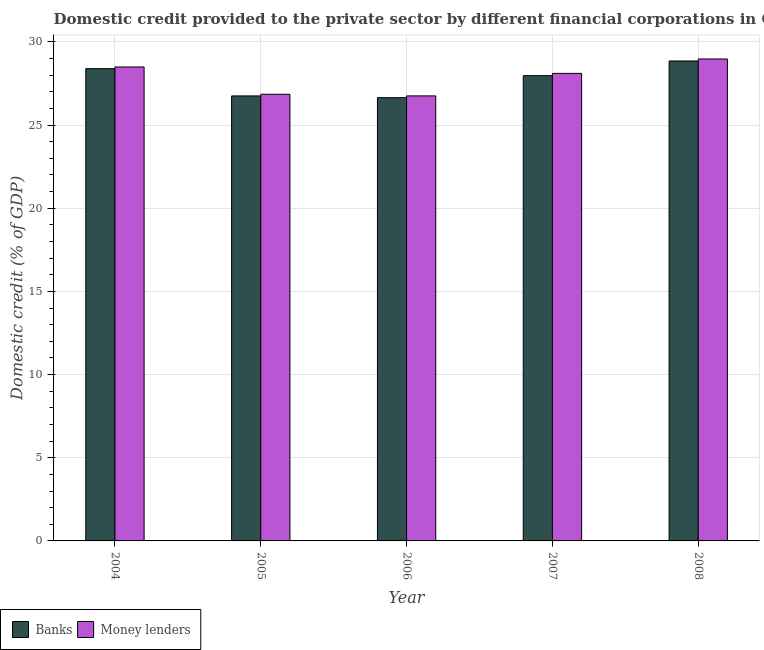How many different coloured bars are there?
Ensure brevity in your answer.  2. Are the number of bars on each tick of the X-axis equal?
Keep it short and to the point. Yes. How many bars are there on the 1st tick from the left?
Provide a short and direct response. 2. How many bars are there on the 5th tick from the right?
Your answer should be very brief. 2. What is the domestic credit provided by money lenders in 2005?
Your answer should be compact. 26.85. Across all years, what is the maximum domestic credit provided by money lenders?
Offer a terse response. 28.97. Across all years, what is the minimum domestic credit provided by money lenders?
Provide a succinct answer. 26.75. In which year was the domestic credit provided by money lenders minimum?
Make the answer very short. 2006. What is the total domestic credit provided by money lenders in the graph?
Ensure brevity in your answer.  139.16. What is the difference between the domestic credit provided by banks in 2005 and that in 2008?
Offer a very short reply. -2.1. What is the difference between the domestic credit provided by money lenders in 2005 and the domestic credit provided by banks in 2004?
Your answer should be very brief. -1.64. What is the average domestic credit provided by money lenders per year?
Make the answer very short. 27.83. What is the ratio of the domestic credit provided by banks in 2006 to that in 2007?
Your response must be concise. 0.95. Is the domestic credit provided by banks in 2005 less than that in 2008?
Offer a very short reply. Yes. What is the difference between the highest and the second highest domestic credit provided by banks?
Offer a terse response. 0.46. What is the difference between the highest and the lowest domestic credit provided by banks?
Your answer should be compact. 2.21. In how many years, is the domestic credit provided by money lenders greater than the average domestic credit provided by money lenders taken over all years?
Your answer should be very brief. 3. Is the sum of the domestic credit provided by money lenders in 2004 and 2005 greater than the maximum domestic credit provided by banks across all years?
Provide a short and direct response. Yes. What does the 2nd bar from the left in 2006 represents?
Keep it short and to the point. Money lenders. What does the 2nd bar from the right in 2006 represents?
Provide a succinct answer. Banks. How many bars are there?
Ensure brevity in your answer.  10. Are all the bars in the graph horizontal?
Offer a very short reply. No. What is the difference between two consecutive major ticks on the Y-axis?
Offer a terse response. 5. Are the values on the major ticks of Y-axis written in scientific E-notation?
Keep it short and to the point. No. Where does the legend appear in the graph?
Your answer should be compact. Bottom left. How many legend labels are there?
Provide a succinct answer. 2. How are the legend labels stacked?
Your answer should be compact. Horizontal. What is the title of the graph?
Your response must be concise. Domestic credit provided to the private sector by different financial corporations in Other small states. What is the label or title of the X-axis?
Make the answer very short. Year. What is the label or title of the Y-axis?
Give a very brief answer. Domestic credit (% of GDP). What is the Domestic credit (% of GDP) in Banks in 2004?
Provide a short and direct response. 28.39. What is the Domestic credit (% of GDP) of Money lenders in 2004?
Provide a succinct answer. 28.49. What is the Domestic credit (% of GDP) of Banks in 2005?
Provide a succinct answer. 26.75. What is the Domestic credit (% of GDP) in Money lenders in 2005?
Provide a short and direct response. 26.85. What is the Domestic credit (% of GDP) in Banks in 2006?
Your answer should be very brief. 26.64. What is the Domestic credit (% of GDP) in Money lenders in 2006?
Offer a terse response. 26.75. What is the Domestic credit (% of GDP) of Banks in 2007?
Ensure brevity in your answer.  27.97. What is the Domestic credit (% of GDP) of Money lenders in 2007?
Offer a very short reply. 28.1. What is the Domestic credit (% of GDP) in Banks in 2008?
Your answer should be very brief. 28.85. What is the Domestic credit (% of GDP) of Money lenders in 2008?
Make the answer very short. 28.97. Across all years, what is the maximum Domestic credit (% of GDP) of Banks?
Your answer should be very brief. 28.85. Across all years, what is the maximum Domestic credit (% of GDP) of Money lenders?
Ensure brevity in your answer.  28.97. Across all years, what is the minimum Domestic credit (% of GDP) of Banks?
Your answer should be very brief. 26.64. Across all years, what is the minimum Domestic credit (% of GDP) of Money lenders?
Provide a succinct answer. 26.75. What is the total Domestic credit (% of GDP) of Banks in the graph?
Give a very brief answer. 138.6. What is the total Domestic credit (% of GDP) in Money lenders in the graph?
Provide a short and direct response. 139.16. What is the difference between the Domestic credit (% of GDP) in Banks in 2004 and that in 2005?
Offer a terse response. 1.64. What is the difference between the Domestic credit (% of GDP) in Money lenders in 2004 and that in 2005?
Offer a very short reply. 1.64. What is the difference between the Domestic credit (% of GDP) in Banks in 2004 and that in 2006?
Provide a succinct answer. 1.74. What is the difference between the Domestic credit (% of GDP) in Money lenders in 2004 and that in 2006?
Your answer should be compact. 1.74. What is the difference between the Domestic credit (% of GDP) in Banks in 2004 and that in 2007?
Your response must be concise. 0.42. What is the difference between the Domestic credit (% of GDP) of Money lenders in 2004 and that in 2007?
Your answer should be compact. 0.38. What is the difference between the Domestic credit (% of GDP) of Banks in 2004 and that in 2008?
Ensure brevity in your answer.  -0.46. What is the difference between the Domestic credit (% of GDP) of Money lenders in 2004 and that in 2008?
Ensure brevity in your answer.  -0.48. What is the difference between the Domestic credit (% of GDP) of Banks in 2005 and that in 2006?
Your answer should be compact. 0.11. What is the difference between the Domestic credit (% of GDP) in Money lenders in 2005 and that in 2006?
Your response must be concise. 0.1. What is the difference between the Domestic credit (% of GDP) of Banks in 2005 and that in 2007?
Your response must be concise. -1.22. What is the difference between the Domestic credit (% of GDP) in Money lenders in 2005 and that in 2007?
Offer a very short reply. -1.25. What is the difference between the Domestic credit (% of GDP) of Banks in 2005 and that in 2008?
Your answer should be compact. -2.1. What is the difference between the Domestic credit (% of GDP) in Money lenders in 2005 and that in 2008?
Offer a terse response. -2.12. What is the difference between the Domestic credit (% of GDP) of Banks in 2006 and that in 2007?
Ensure brevity in your answer.  -1.32. What is the difference between the Domestic credit (% of GDP) of Money lenders in 2006 and that in 2007?
Offer a very short reply. -1.35. What is the difference between the Domestic credit (% of GDP) of Banks in 2006 and that in 2008?
Your answer should be very brief. -2.21. What is the difference between the Domestic credit (% of GDP) in Money lenders in 2006 and that in 2008?
Your response must be concise. -2.22. What is the difference between the Domestic credit (% of GDP) of Banks in 2007 and that in 2008?
Make the answer very short. -0.88. What is the difference between the Domestic credit (% of GDP) in Money lenders in 2007 and that in 2008?
Your answer should be compact. -0.87. What is the difference between the Domestic credit (% of GDP) in Banks in 2004 and the Domestic credit (% of GDP) in Money lenders in 2005?
Offer a very short reply. 1.54. What is the difference between the Domestic credit (% of GDP) in Banks in 2004 and the Domestic credit (% of GDP) in Money lenders in 2006?
Provide a succinct answer. 1.64. What is the difference between the Domestic credit (% of GDP) in Banks in 2004 and the Domestic credit (% of GDP) in Money lenders in 2007?
Your response must be concise. 0.28. What is the difference between the Domestic credit (% of GDP) in Banks in 2004 and the Domestic credit (% of GDP) in Money lenders in 2008?
Provide a succinct answer. -0.58. What is the difference between the Domestic credit (% of GDP) of Banks in 2005 and the Domestic credit (% of GDP) of Money lenders in 2006?
Make the answer very short. -0. What is the difference between the Domestic credit (% of GDP) in Banks in 2005 and the Domestic credit (% of GDP) in Money lenders in 2007?
Your answer should be compact. -1.35. What is the difference between the Domestic credit (% of GDP) of Banks in 2005 and the Domestic credit (% of GDP) of Money lenders in 2008?
Your answer should be compact. -2.22. What is the difference between the Domestic credit (% of GDP) of Banks in 2006 and the Domestic credit (% of GDP) of Money lenders in 2007?
Keep it short and to the point. -1.46. What is the difference between the Domestic credit (% of GDP) of Banks in 2006 and the Domestic credit (% of GDP) of Money lenders in 2008?
Offer a terse response. -2.33. What is the difference between the Domestic credit (% of GDP) in Banks in 2007 and the Domestic credit (% of GDP) in Money lenders in 2008?
Provide a succinct answer. -1. What is the average Domestic credit (% of GDP) of Banks per year?
Keep it short and to the point. 27.72. What is the average Domestic credit (% of GDP) in Money lenders per year?
Give a very brief answer. 27.83. In the year 2004, what is the difference between the Domestic credit (% of GDP) of Banks and Domestic credit (% of GDP) of Money lenders?
Your response must be concise. -0.1. In the year 2005, what is the difference between the Domestic credit (% of GDP) of Banks and Domestic credit (% of GDP) of Money lenders?
Offer a terse response. -0.1. In the year 2006, what is the difference between the Domestic credit (% of GDP) of Banks and Domestic credit (% of GDP) of Money lenders?
Your answer should be very brief. -0.11. In the year 2007, what is the difference between the Domestic credit (% of GDP) of Banks and Domestic credit (% of GDP) of Money lenders?
Your response must be concise. -0.14. In the year 2008, what is the difference between the Domestic credit (% of GDP) in Banks and Domestic credit (% of GDP) in Money lenders?
Your answer should be very brief. -0.12. What is the ratio of the Domestic credit (% of GDP) in Banks in 2004 to that in 2005?
Offer a very short reply. 1.06. What is the ratio of the Domestic credit (% of GDP) in Money lenders in 2004 to that in 2005?
Your answer should be very brief. 1.06. What is the ratio of the Domestic credit (% of GDP) of Banks in 2004 to that in 2006?
Ensure brevity in your answer.  1.07. What is the ratio of the Domestic credit (% of GDP) of Money lenders in 2004 to that in 2006?
Your answer should be compact. 1.06. What is the ratio of the Domestic credit (% of GDP) of Money lenders in 2004 to that in 2007?
Provide a short and direct response. 1.01. What is the ratio of the Domestic credit (% of GDP) of Banks in 2004 to that in 2008?
Offer a very short reply. 0.98. What is the ratio of the Domestic credit (% of GDP) in Money lenders in 2004 to that in 2008?
Your response must be concise. 0.98. What is the ratio of the Domestic credit (% of GDP) of Money lenders in 2005 to that in 2006?
Keep it short and to the point. 1. What is the ratio of the Domestic credit (% of GDP) in Banks in 2005 to that in 2007?
Offer a very short reply. 0.96. What is the ratio of the Domestic credit (% of GDP) in Money lenders in 2005 to that in 2007?
Provide a short and direct response. 0.96. What is the ratio of the Domestic credit (% of GDP) of Banks in 2005 to that in 2008?
Keep it short and to the point. 0.93. What is the ratio of the Domestic credit (% of GDP) in Money lenders in 2005 to that in 2008?
Keep it short and to the point. 0.93. What is the ratio of the Domestic credit (% of GDP) of Banks in 2006 to that in 2007?
Make the answer very short. 0.95. What is the ratio of the Domestic credit (% of GDP) of Money lenders in 2006 to that in 2007?
Your answer should be compact. 0.95. What is the ratio of the Domestic credit (% of GDP) in Banks in 2006 to that in 2008?
Your answer should be compact. 0.92. What is the ratio of the Domestic credit (% of GDP) of Money lenders in 2006 to that in 2008?
Make the answer very short. 0.92. What is the ratio of the Domestic credit (% of GDP) of Banks in 2007 to that in 2008?
Make the answer very short. 0.97. What is the ratio of the Domestic credit (% of GDP) in Money lenders in 2007 to that in 2008?
Keep it short and to the point. 0.97. What is the difference between the highest and the second highest Domestic credit (% of GDP) of Banks?
Offer a very short reply. 0.46. What is the difference between the highest and the second highest Domestic credit (% of GDP) in Money lenders?
Your answer should be compact. 0.48. What is the difference between the highest and the lowest Domestic credit (% of GDP) in Banks?
Your response must be concise. 2.21. What is the difference between the highest and the lowest Domestic credit (% of GDP) in Money lenders?
Your answer should be very brief. 2.22. 